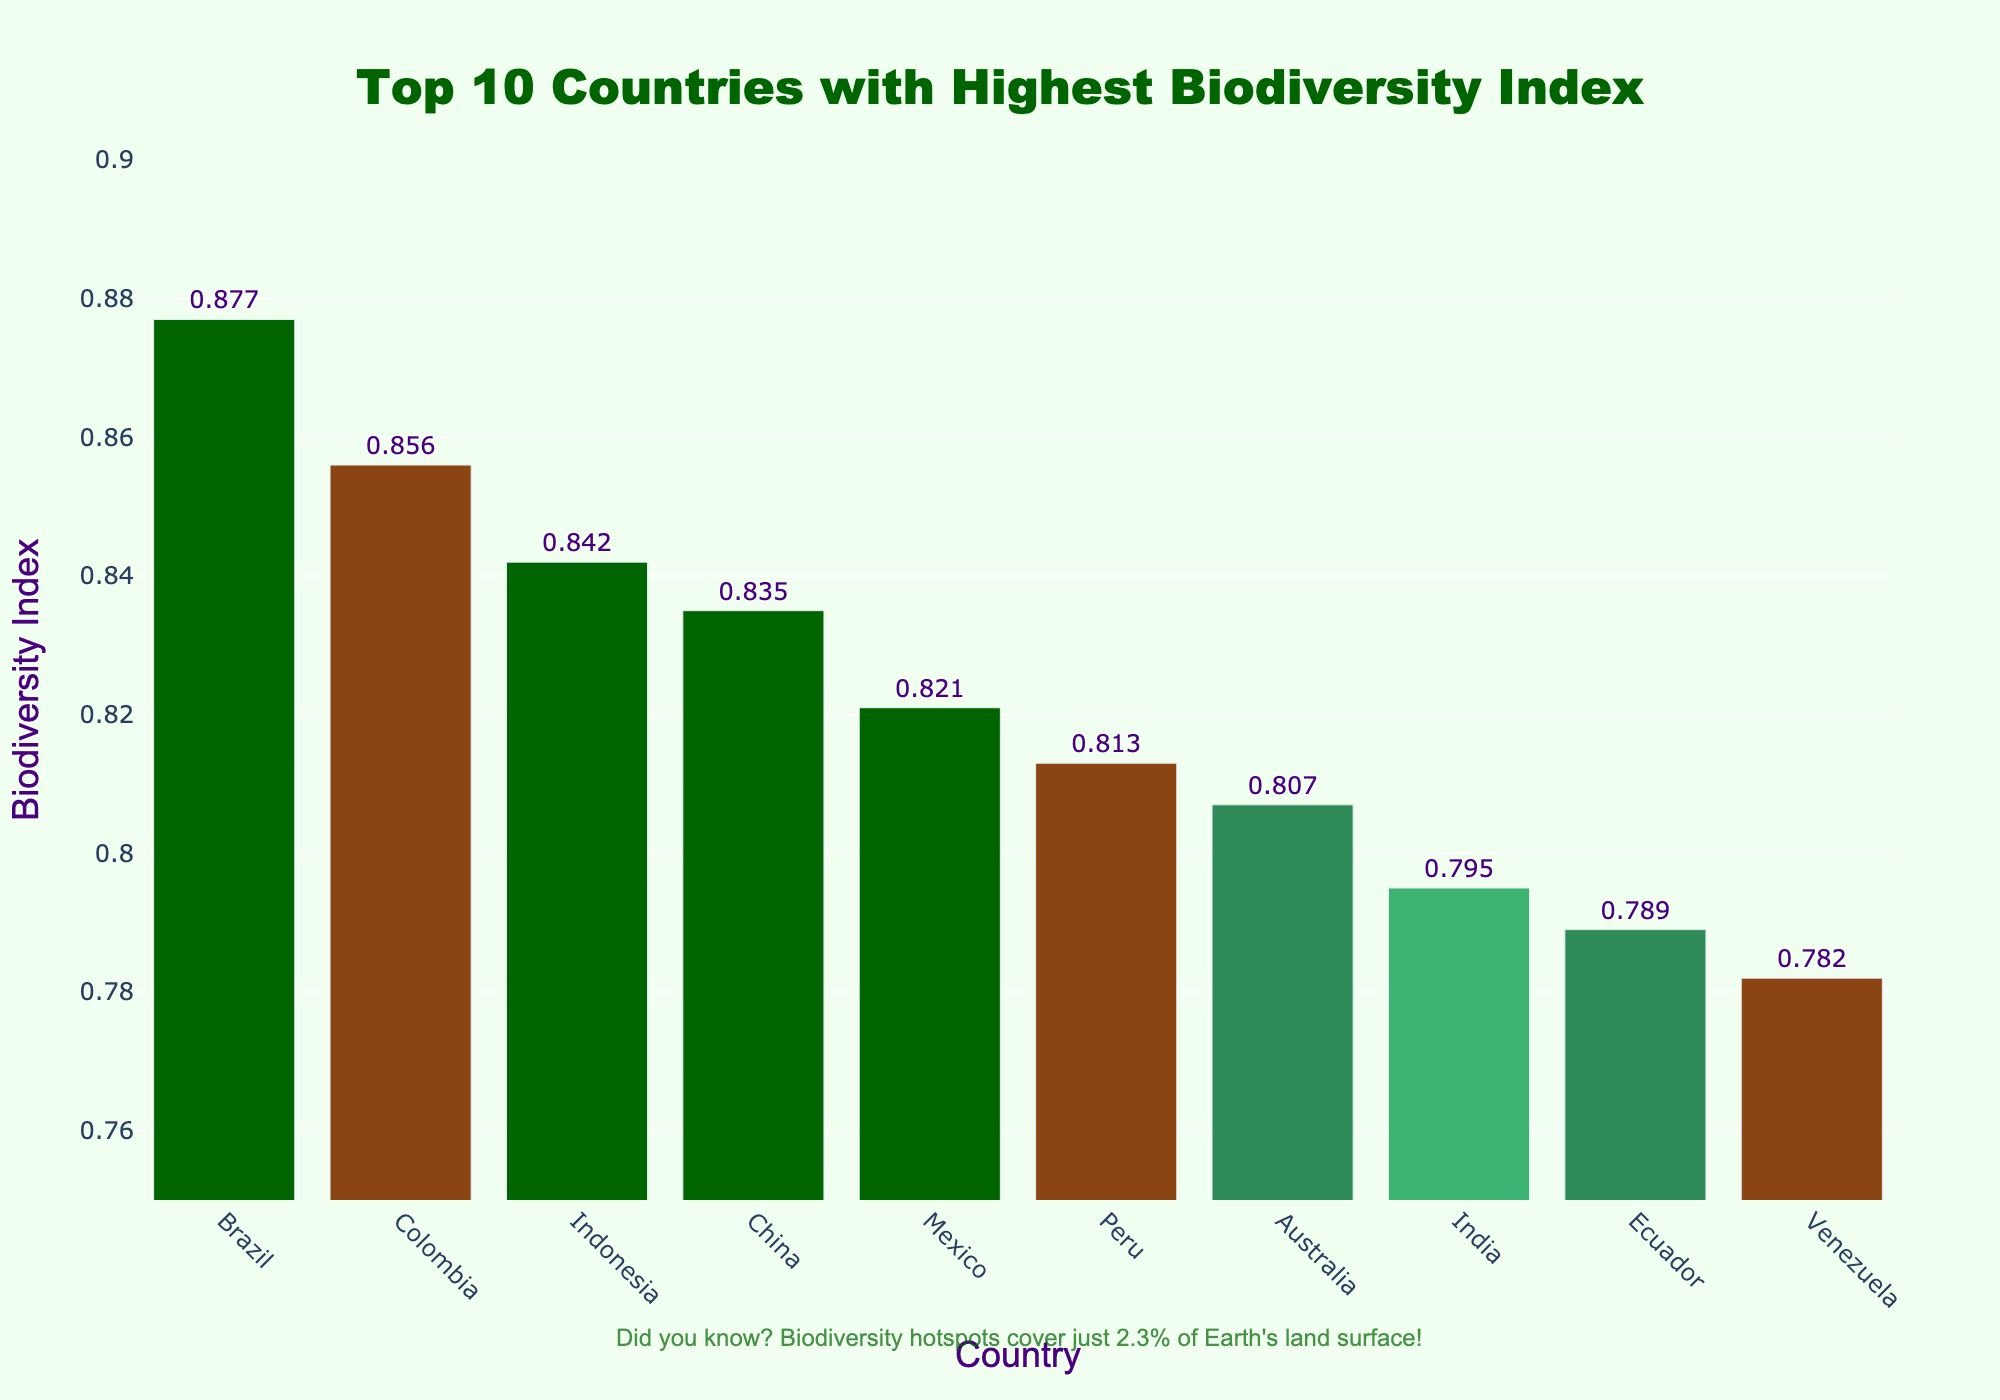What is the country with the highest biodiversity index in the chart? The chart shows biodiversity indices for the top 10 countries. The highest bar represents Brazil with a biodiversity index of 0.877.
Answer: Brazil Which country has the smallest biodiversity index among the top 10 listed? By looking at the bars, the shortest one corresponds to Venezuela with a biodiversity index of 0.782.
Answer: Venezuela What is the difference in biodiversity index between Brazil and Venezuela? Subtract the biodiversity index of Venezuela (0.782) from Brazil’s index (0.877): 0.877 - 0.782 = 0.095.
Answer: 0.095 How many countries in the chart have a biodiversity index greater than 0.8? Count the number of bars where the biodiversity index exceeds 0.8: Brazil, Colombia, Indonesia, China, Mexico, and Peru. There are 6 countries in total.
Answer: 6 Which two countries have the closest biodiversity indices? Checking the values, China (0.835) and Mexico (0.821) are closest with a difference of 0.014.
Answer: China and Mexico What is the average biodiversity index of the top 10 countries? Sum the biodiversity indices of the top 10 countries: (0.877+0.856+0.842+0.835+0.821+0.813+0.807+0.795+0.789+0.782) = 8.517. Divide by 10 to get the average: 8.517 / 10 = 0.852.
Answer: 0.852 How much higher is Brazil's biodiversity index compared to India? Calculate the difference: 0.877 (Brazil) - 0.795 (India) = 0.082.
Answer: 0.082 Rank the countries shown in terms of biodiversity index from highest to lowest? Order the countries based on bar heights starting from the highest: Brazil, Colombia, Indonesia, China, Mexico, Peru, Australia, India, Ecuador, Venezuela.
Answer: Brazil, Colombia, Indonesia, China, Mexico, Peru, Australia, India, Ecuador, Venezuela 